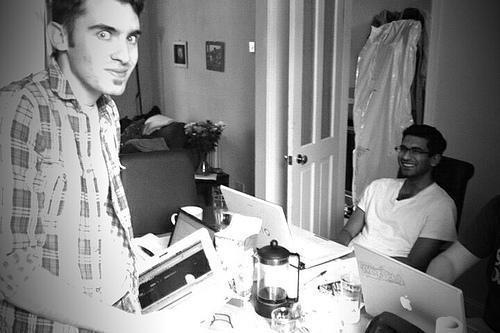How does the seated man think the standing man is acting?
From the following set of four choices, select the accurate answer to respond to the question.
Options: Guilty, funny, depressed, whiny. Funny. 